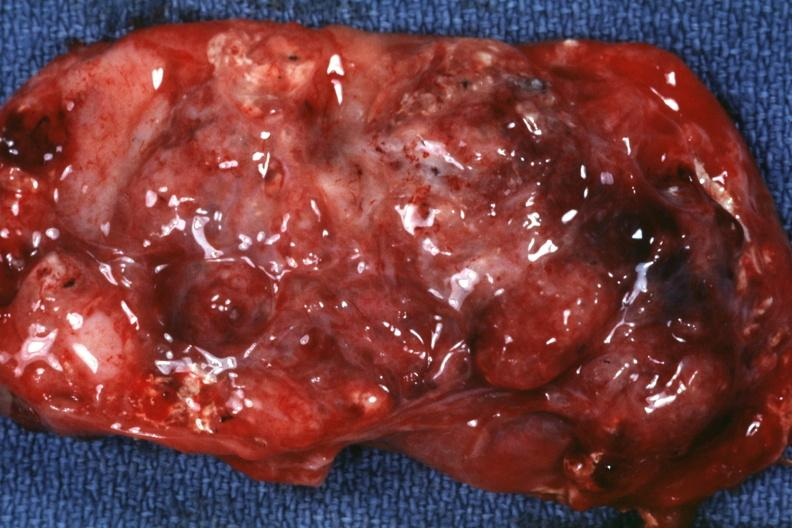does this image show excised tumor mass?
Answer the question using a single word or phrase. Yes 